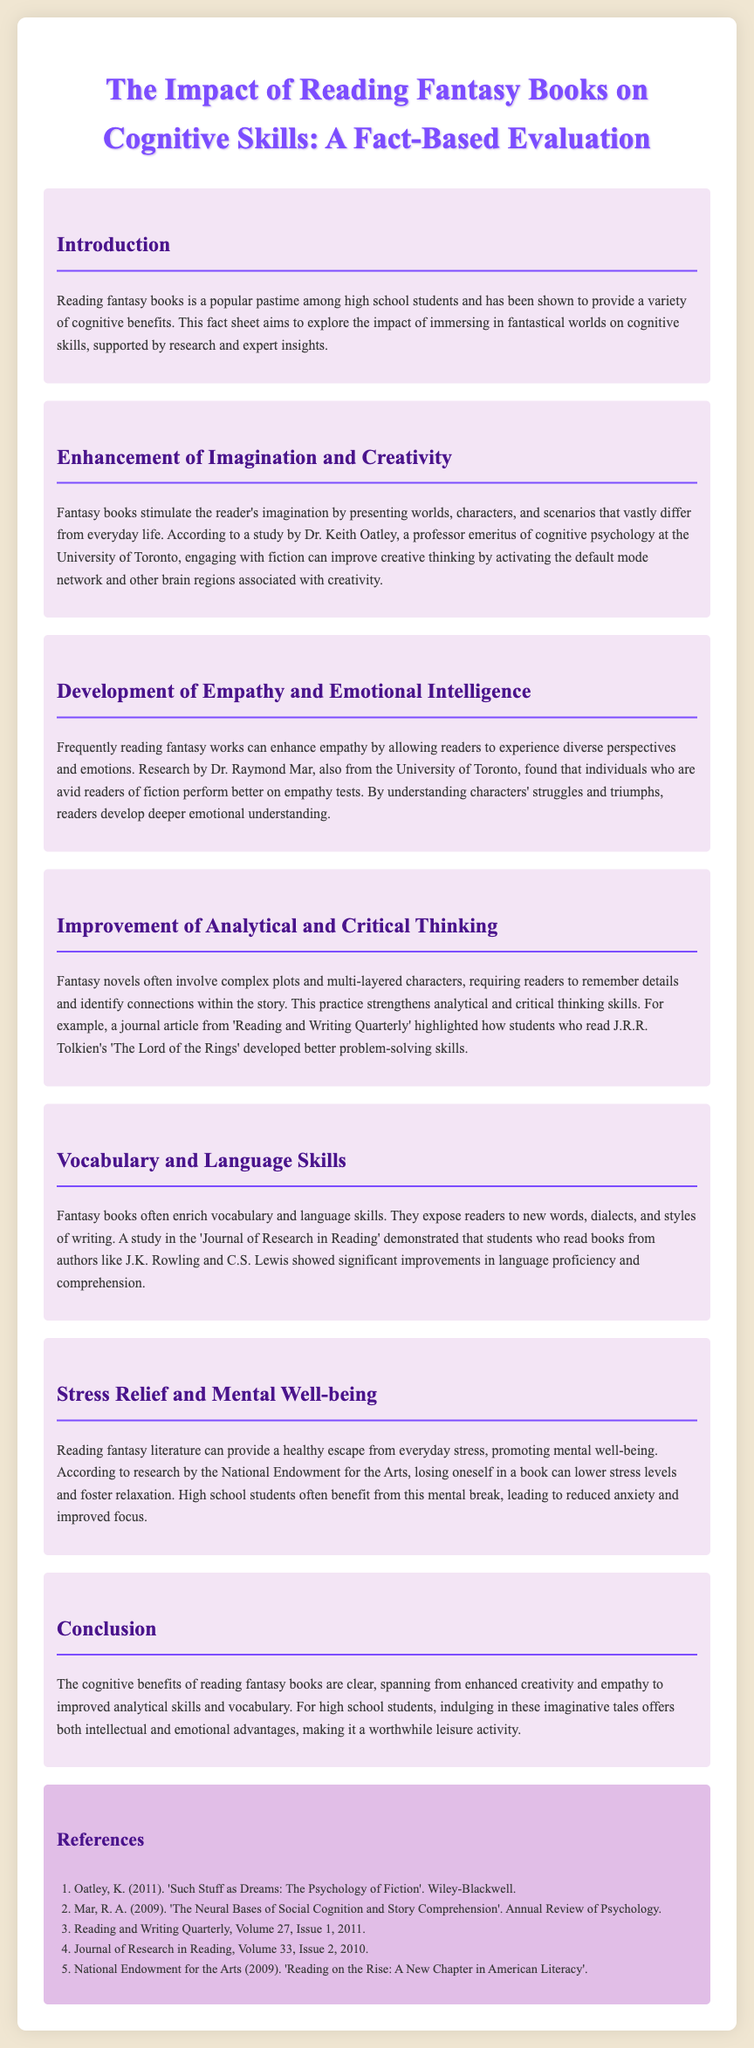What is the title of the document? The title of the document is provided at the beginning as "The Impact of Reading Fantasy Books on Cognitive Skills: A Fact-Based Evaluation."
Answer: The Impact of Reading Fantasy Books on Cognitive Skills: A Fact-Based Evaluation Who conducted the study on imagination and creativity? The document mentions Dr. Keith Oatley as the professor emeritus of cognitive psychology who conducted the study.
Answer: Dr. Keith Oatley Which skills are enhanced by reading fantasy books according to the conclusion? The conclusion summarizes the skills enhanced by reading fantasy books, which include creativity, empathy, analytical skills, and vocabulary.
Answer: Creativity, empathy, analytical skills, vocabulary What cognitive benefit involves experiencing diverse perspectives? The document discusses the development of empathy and emotional intelligence as a cognitive benefit involving diverse perspectives.
Answer: Empathy and emotional intelligence Which author's books were linked to improvements in language proficiency? The study in the document states that students who read books from J.K. Rowling showed improvements in language proficiency.
Answer: J.K. Rowling What is one way fantasy literature helps high school students, according to the document? The document indicates that fantasy literature helps students by providing stress relief and promoting mental well-being.
Answer: Stress relief and mental well-being In which journal was the article highlighting problem-solving skills published? The document references an article published in 'Reading and Writing Quarterly' that discusses problem-solving skills.
Answer: Reading and Writing Quarterly What year does the National Endowment for the Arts report mention? The document states that the National Endowment for the Arts report was published in 2009.
Answer: 2009 